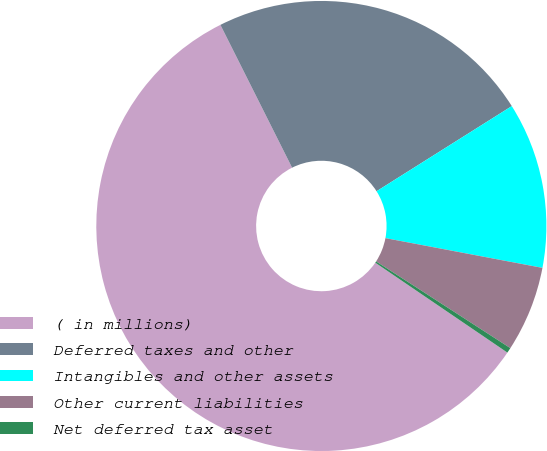Convert chart to OTSL. <chart><loc_0><loc_0><loc_500><loc_500><pie_chart><fcel>( in millions)<fcel>Deferred taxes and other<fcel>Intangibles and other assets<fcel>Other current liabilities<fcel>Net deferred tax asset<nl><fcel>58.08%<fcel>23.46%<fcel>11.92%<fcel>6.15%<fcel>0.38%<nl></chart> 